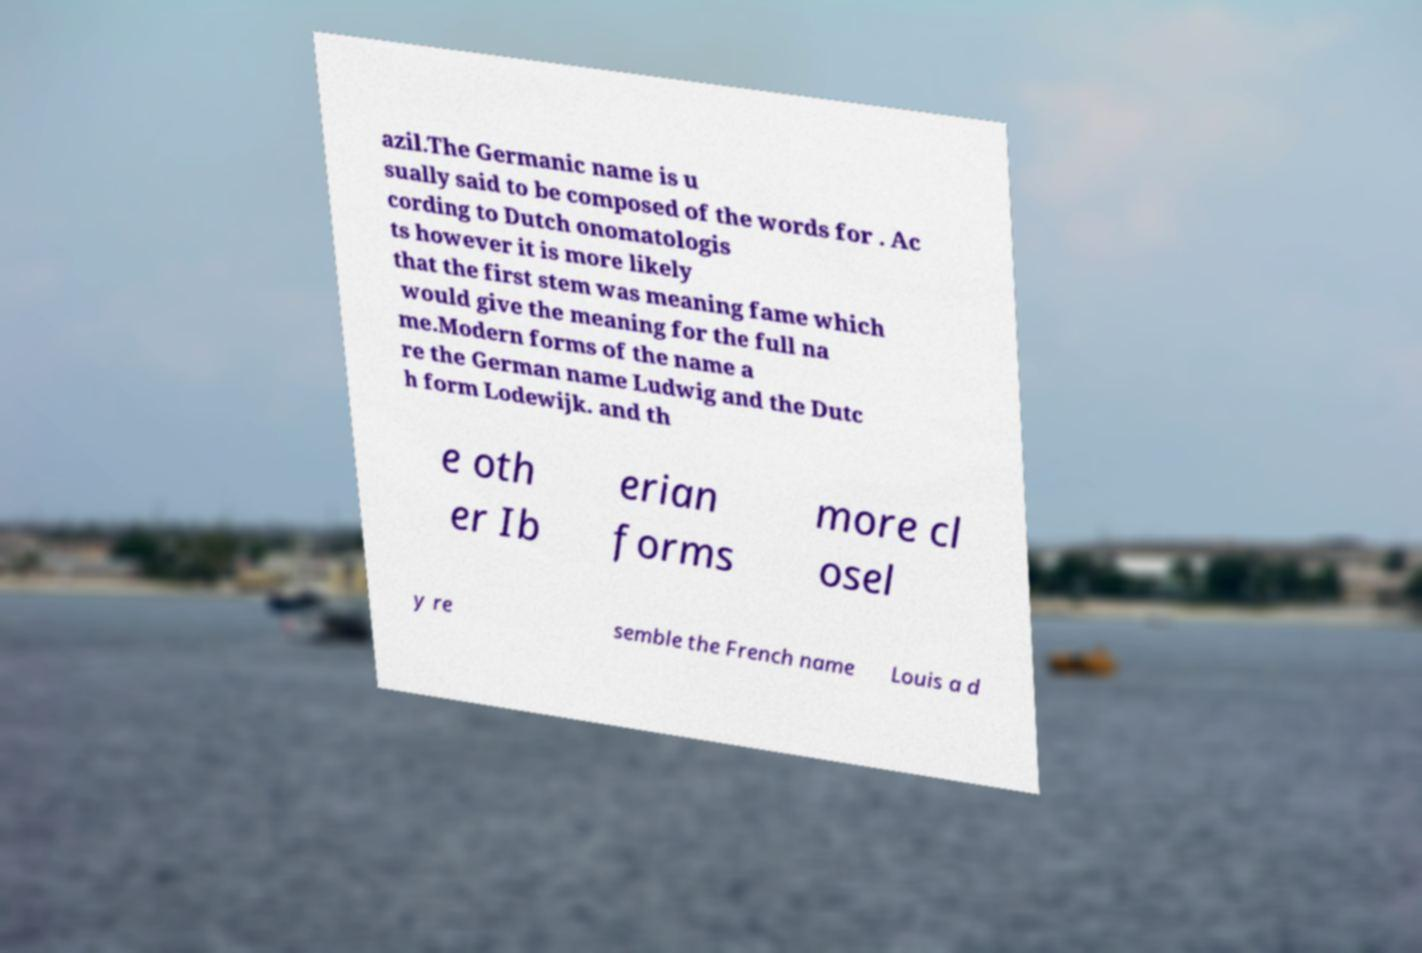Could you assist in decoding the text presented in this image and type it out clearly? azil.The Germanic name is u sually said to be composed of the words for . Ac cording to Dutch onomatologis ts however it is more likely that the first stem was meaning fame which would give the meaning for the full na me.Modern forms of the name a re the German name Ludwig and the Dutc h form Lodewijk. and th e oth er Ib erian forms more cl osel y re semble the French name Louis a d 